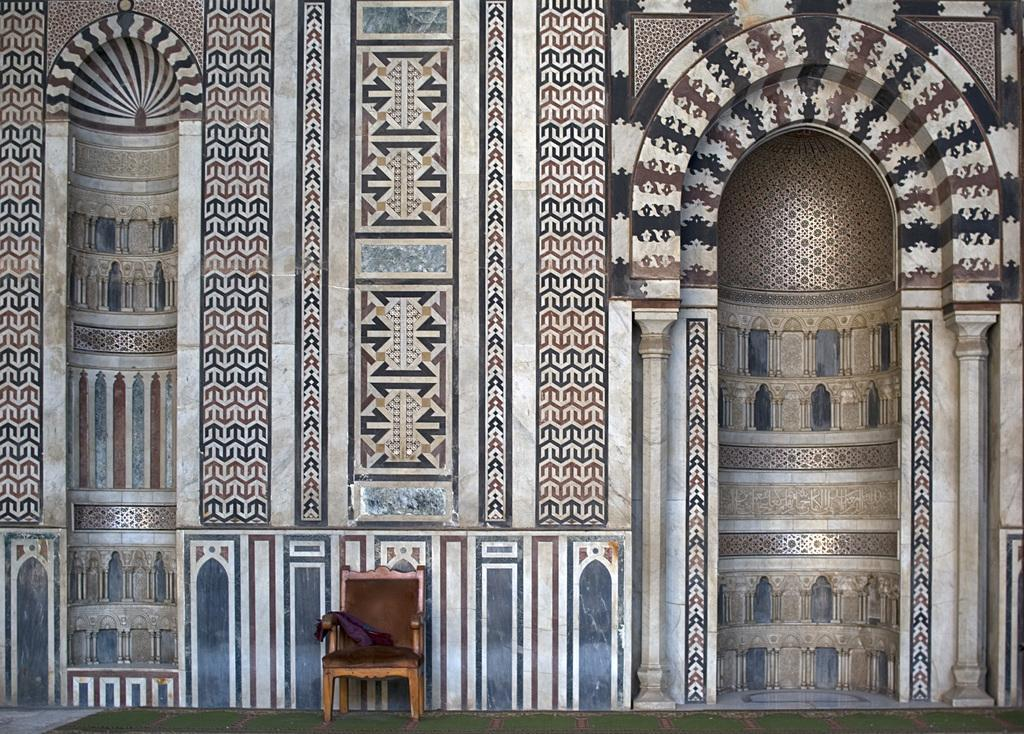What type of building is shown in the image? The image appears to depict a palace. What is located in front of the palace? There is a wall in front of the palace. What is placed in front of the wall? There is a chair in front of the wall. What is on the chair? An object is kept on the chair. How many crates are stacked on top of the vest in the image? There are no crates or vests present in the image. 